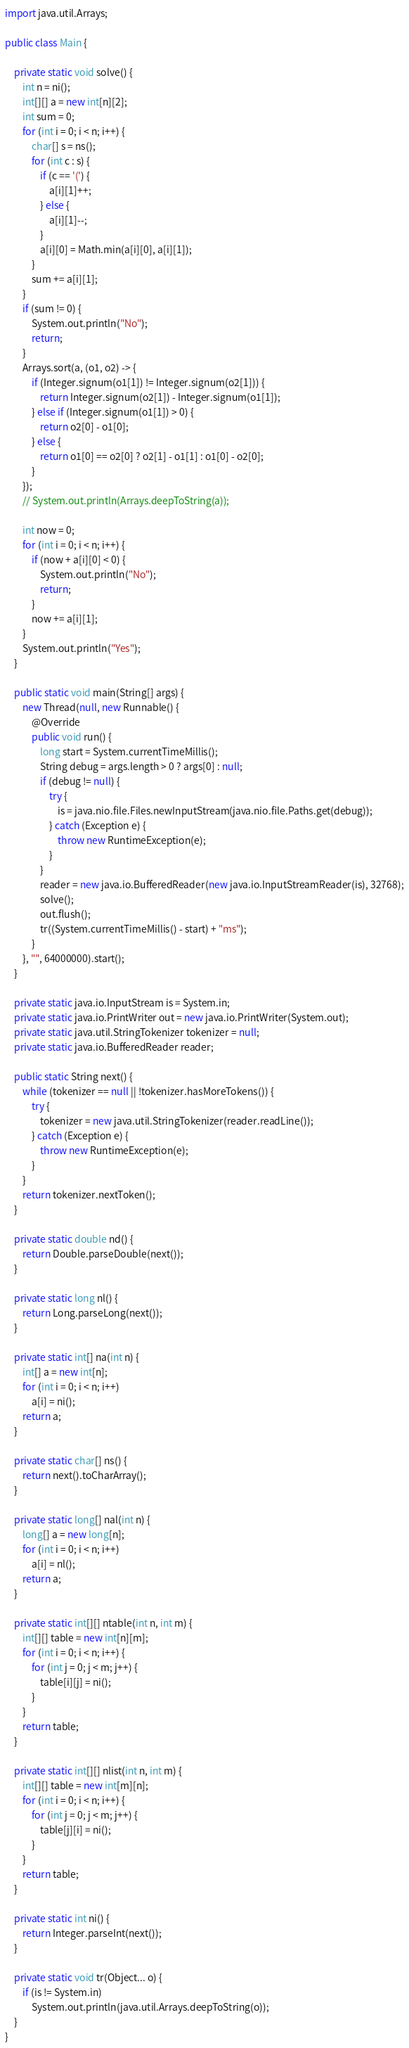Convert code to text. <code><loc_0><loc_0><loc_500><loc_500><_Java_>import java.util.Arrays;

public class Main {

    private static void solve() {
        int n = ni();
        int[][] a = new int[n][2];
        int sum = 0;
        for (int i = 0; i < n; i++) {
            char[] s = ns();
            for (int c : s) {
                if (c == '(') {
                    a[i][1]++;
                } else {
                    a[i][1]--;
                }
                a[i][0] = Math.min(a[i][0], a[i][1]);
            }
            sum += a[i][1];
        }
        if (sum != 0) {
            System.out.println("No");
            return;
        }
        Arrays.sort(a, (o1, o2) -> {
            if (Integer.signum(o1[1]) != Integer.signum(o2[1])) {
                return Integer.signum(o2[1]) - Integer.signum(o1[1]);
            } else if (Integer.signum(o1[1]) > 0) {
                return o2[0] - o1[0];
            } else {
                return o1[0] == o2[0] ? o2[1] - o1[1] : o1[0] - o2[0];
            }
        });
        // System.out.println(Arrays.deepToString(a));

        int now = 0;
        for (int i = 0; i < n; i++) {
            if (now + a[i][0] < 0) {
                System.out.println("No");
                return;
            }
            now += a[i][1];
        }
        System.out.println("Yes");
    }

    public static void main(String[] args) {
        new Thread(null, new Runnable() {
            @Override
            public void run() {
                long start = System.currentTimeMillis();
                String debug = args.length > 0 ? args[0] : null;
                if (debug != null) {
                    try {
                        is = java.nio.file.Files.newInputStream(java.nio.file.Paths.get(debug));
                    } catch (Exception e) {
                        throw new RuntimeException(e);
                    }
                }
                reader = new java.io.BufferedReader(new java.io.InputStreamReader(is), 32768);
                solve();
                out.flush();
                tr((System.currentTimeMillis() - start) + "ms");
            }
        }, "", 64000000).start();
    }

    private static java.io.InputStream is = System.in;
    private static java.io.PrintWriter out = new java.io.PrintWriter(System.out);
    private static java.util.StringTokenizer tokenizer = null;
    private static java.io.BufferedReader reader;

    public static String next() {
        while (tokenizer == null || !tokenizer.hasMoreTokens()) {
            try {
                tokenizer = new java.util.StringTokenizer(reader.readLine());
            } catch (Exception e) {
                throw new RuntimeException(e);
            }
        }
        return tokenizer.nextToken();
    }

    private static double nd() {
        return Double.parseDouble(next());
    }

    private static long nl() {
        return Long.parseLong(next());
    }

    private static int[] na(int n) {
        int[] a = new int[n];
        for (int i = 0; i < n; i++)
            a[i] = ni();
        return a;
    }

    private static char[] ns() {
        return next().toCharArray();
    }

    private static long[] nal(int n) {
        long[] a = new long[n];
        for (int i = 0; i < n; i++)
            a[i] = nl();
        return a;
    }

    private static int[][] ntable(int n, int m) {
        int[][] table = new int[n][m];
        for (int i = 0; i < n; i++) {
            for (int j = 0; j < m; j++) {
                table[i][j] = ni();
            }
        }
        return table;
    }

    private static int[][] nlist(int n, int m) {
        int[][] table = new int[m][n];
        for (int i = 0; i < n; i++) {
            for (int j = 0; j < m; j++) {
                table[j][i] = ni();
            }
        }
        return table;
    }

    private static int ni() {
        return Integer.parseInt(next());
    }

    private static void tr(Object... o) {
        if (is != System.in)
            System.out.println(java.util.Arrays.deepToString(o));
    }
}
</code> 